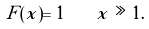Convert formula to latex. <formula><loc_0><loc_0><loc_500><loc_500>F ( x ) = 1 \quad x \gg 1 .</formula> 